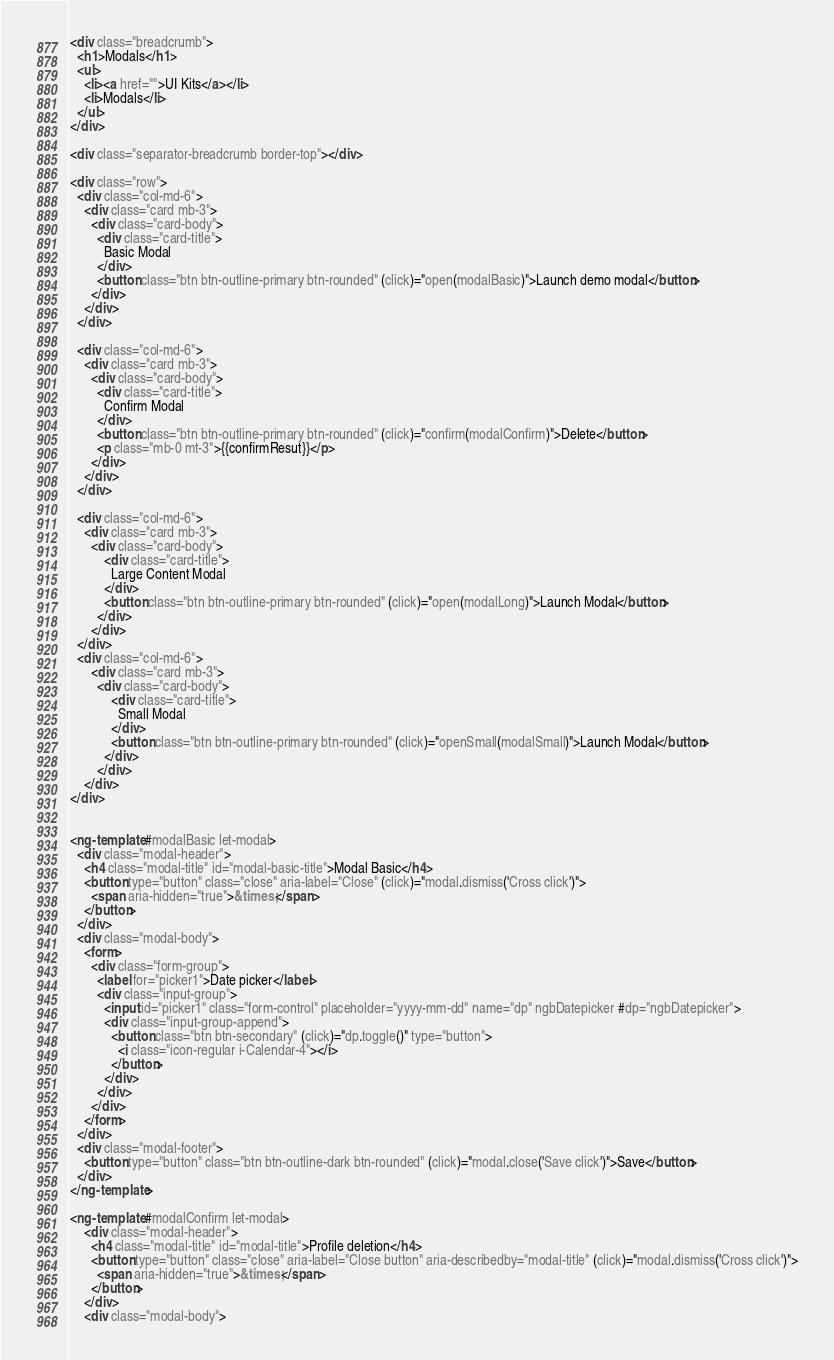Convert code to text. <code><loc_0><loc_0><loc_500><loc_500><_HTML_><div class="breadcrumb">
  <h1>Modals</h1>
  <ul>
    <li><a href="">UI Kits</a></li>
    <li>Modals</li>
  </ul>
</div>

<div class="separator-breadcrumb border-top"></div>

<div class="row">
  <div class="col-md-6">
    <div class="card mb-3">
      <div class="card-body">
        <div class="card-title">
          Basic Modal
        </div>
        <button class="btn btn-outline-primary btn-rounded" (click)="open(modalBasic)">Launch demo modal</button>
      </div>
    </div>
  </div>

  <div class="col-md-6">
    <div class="card mb-3">
      <div class="card-body">
        <div class="card-title">
          Confirm Modal
        </div>
        <button class="btn btn-outline-primary btn-rounded" (click)="confirm(modalConfirm)">Delete</button>
        <p class="mb-0 mt-3">{{confirmResut}}</p>
      </div>
    </div>
  </div>

  <div class="col-md-6">
    <div class="card mb-3">
      <div class="card-body">
          <div class="card-title">
            Large Content Modal
          </div>
          <button class="btn btn-outline-primary btn-rounded" (click)="open(modalLong)">Launch Modal</button>
        </div>
      </div>
  </div>
  <div class="col-md-6">
      <div class="card mb-3">
        <div class="card-body">
            <div class="card-title">
              Small Modal
            </div>
            <button class="btn btn-outline-primary btn-rounded" (click)="openSmall(modalSmall)">Launch Modal</button>
          </div>
        </div>
    </div>
</div>


<ng-template #modalBasic let-modal>
  <div class="modal-header">
    <h4 class="modal-title" id="modal-basic-title">Modal Basic</h4>
    <button type="button" class="close" aria-label="Close" (click)="modal.dismiss('Cross click')">
      <span aria-hidden="true">&times;</span>
    </button>
  </div>
  <div class="modal-body">
    <form>
      <div class="form-group">
        <label for="picker1">Date picker</label>
        <div class="input-group">
          <input id="picker1" class="form-control" placeholder="yyyy-mm-dd" name="dp" ngbDatepicker #dp="ngbDatepicker">
          <div class="input-group-append">
            <button class="btn btn-secondary" (click)="dp.toggle()" type="button">
              <i class="icon-regular i-Calendar-4"></i>
            </button>
          </div>
        </div>
      </div>
    </form>
  </div>
  <div class="modal-footer">
    <button type="button" class="btn btn-outline-dark btn-rounded" (click)="modal.close('Save click')">Save</button>
  </div>
</ng-template>

<ng-template #modalConfirm let-modal>
    <div class="modal-header">
      <h4 class="modal-title" id="modal-title">Profile deletion</h4>
      <button type="button" class="close" aria-label="Close button" aria-describedby="modal-title" (click)="modal.dismiss('Cross click')">
        <span aria-hidden="true">&times;</span>
      </button>
    </div>
    <div class="modal-body"></code> 